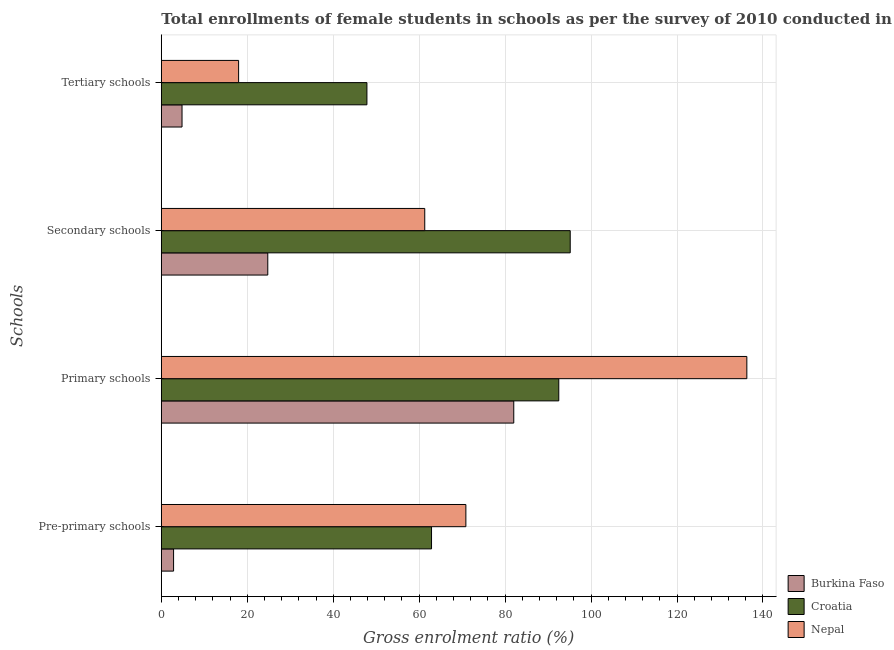How many different coloured bars are there?
Offer a very short reply. 3. How many groups of bars are there?
Offer a very short reply. 4. Are the number of bars per tick equal to the number of legend labels?
Ensure brevity in your answer.  Yes. Are the number of bars on each tick of the Y-axis equal?
Make the answer very short. Yes. What is the label of the 2nd group of bars from the top?
Provide a succinct answer. Secondary schools. What is the gross enrolment ratio(female) in primary schools in Croatia?
Provide a succinct answer. 92.49. Across all countries, what is the maximum gross enrolment ratio(female) in tertiary schools?
Make the answer very short. 47.84. Across all countries, what is the minimum gross enrolment ratio(female) in secondary schools?
Offer a very short reply. 24.77. In which country was the gross enrolment ratio(female) in primary schools maximum?
Offer a terse response. Nepal. In which country was the gross enrolment ratio(female) in primary schools minimum?
Your answer should be compact. Burkina Faso. What is the total gross enrolment ratio(female) in secondary schools in the graph?
Provide a short and direct response. 181.22. What is the difference between the gross enrolment ratio(female) in primary schools in Croatia and that in Nepal?
Provide a succinct answer. -43.76. What is the difference between the gross enrolment ratio(female) in secondary schools in Burkina Faso and the gross enrolment ratio(female) in pre-primary schools in Croatia?
Keep it short and to the point. -38.1. What is the average gross enrolment ratio(female) in primary schools per country?
Your answer should be very brief. 103.58. What is the difference between the gross enrolment ratio(female) in tertiary schools and gross enrolment ratio(female) in secondary schools in Nepal?
Ensure brevity in your answer.  -43.31. What is the ratio of the gross enrolment ratio(female) in pre-primary schools in Croatia to that in Burkina Faso?
Your response must be concise. 22.03. Is the gross enrolment ratio(female) in secondary schools in Croatia less than that in Burkina Faso?
Offer a terse response. No. What is the difference between the highest and the second highest gross enrolment ratio(female) in pre-primary schools?
Your answer should be compact. 7.99. What is the difference between the highest and the lowest gross enrolment ratio(female) in tertiary schools?
Give a very brief answer. 43.02. In how many countries, is the gross enrolment ratio(female) in primary schools greater than the average gross enrolment ratio(female) in primary schools taken over all countries?
Your response must be concise. 1. Is it the case that in every country, the sum of the gross enrolment ratio(female) in secondary schools and gross enrolment ratio(female) in tertiary schools is greater than the sum of gross enrolment ratio(female) in primary schools and gross enrolment ratio(female) in pre-primary schools?
Offer a terse response. No. What does the 2nd bar from the top in Primary schools represents?
Your answer should be very brief. Croatia. What does the 1st bar from the bottom in Primary schools represents?
Keep it short and to the point. Burkina Faso. Is it the case that in every country, the sum of the gross enrolment ratio(female) in pre-primary schools and gross enrolment ratio(female) in primary schools is greater than the gross enrolment ratio(female) in secondary schools?
Offer a very short reply. Yes. Are all the bars in the graph horizontal?
Make the answer very short. Yes. How many countries are there in the graph?
Offer a terse response. 3. Are the values on the major ticks of X-axis written in scientific E-notation?
Your answer should be very brief. No. Where does the legend appear in the graph?
Give a very brief answer. Bottom right. How are the legend labels stacked?
Offer a terse response. Vertical. What is the title of the graph?
Provide a succinct answer. Total enrollments of female students in schools as per the survey of 2010 conducted in different countries. Does "Guinea" appear as one of the legend labels in the graph?
Your response must be concise. No. What is the label or title of the Y-axis?
Offer a very short reply. Schools. What is the Gross enrolment ratio (%) in Burkina Faso in Pre-primary schools?
Provide a succinct answer. 2.85. What is the Gross enrolment ratio (%) of Croatia in Pre-primary schools?
Your answer should be compact. 62.87. What is the Gross enrolment ratio (%) in Nepal in Pre-primary schools?
Offer a terse response. 70.87. What is the Gross enrolment ratio (%) of Burkina Faso in Primary schools?
Make the answer very short. 82.01. What is the Gross enrolment ratio (%) in Croatia in Primary schools?
Provide a succinct answer. 92.49. What is the Gross enrolment ratio (%) of Nepal in Primary schools?
Provide a short and direct response. 136.24. What is the Gross enrolment ratio (%) of Burkina Faso in Secondary schools?
Make the answer very short. 24.77. What is the Gross enrolment ratio (%) in Croatia in Secondary schools?
Provide a succinct answer. 95.15. What is the Gross enrolment ratio (%) of Nepal in Secondary schools?
Make the answer very short. 61.3. What is the Gross enrolment ratio (%) in Burkina Faso in Tertiary schools?
Your answer should be very brief. 4.82. What is the Gross enrolment ratio (%) in Croatia in Tertiary schools?
Provide a succinct answer. 47.84. What is the Gross enrolment ratio (%) in Nepal in Tertiary schools?
Offer a very short reply. 17.99. Across all Schools, what is the maximum Gross enrolment ratio (%) of Burkina Faso?
Offer a terse response. 82.01. Across all Schools, what is the maximum Gross enrolment ratio (%) in Croatia?
Keep it short and to the point. 95.15. Across all Schools, what is the maximum Gross enrolment ratio (%) of Nepal?
Give a very brief answer. 136.24. Across all Schools, what is the minimum Gross enrolment ratio (%) in Burkina Faso?
Your answer should be compact. 2.85. Across all Schools, what is the minimum Gross enrolment ratio (%) of Croatia?
Make the answer very short. 47.84. Across all Schools, what is the minimum Gross enrolment ratio (%) of Nepal?
Your answer should be compact. 17.99. What is the total Gross enrolment ratio (%) of Burkina Faso in the graph?
Offer a very short reply. 114.46. What is the total Gross enrolment ratio (%) in Croatia in the graph?
Offer a very short reply. 298.35. What is the total Gross enrolment ratio (%) in Nepal in the graph?
Your response must be concise. 286.4. What is the difference between the Gross enrolment ratio (%) of Burkina Faso in Pre-primary schools and that in Primary schools?
Ensure brevity in your answer.  -79.16. What is the difference between the Gross enrolment ratio (%) in Croatia in Pre-primary schools and that in Primary schools?
Offer a terse response. -29.61. What is the difference between the Gross enrolment ratio (%) of Nepal in Pre-primary schools and that in Primary schools?
Make the answer very short. -65.38. What is the difference between the Gross enrolment ratio (%) in Burkina Faso in Pre-primary schools and that in Secondary schools?
Ensure brevity in your answer.  -21.92. What is the difference between the Gross enrolment ratio (%) in Croatia in Pre-primary schools and that in Secondary schools?
Keep it short and to the point. -32.27. What is the difference between the Gross enrolment ratio (%) in Nepal in Pre-primary schools and that in Secondary schools?
Provide a short and direct response. 9.57. What is the difference between the Gross enrolment ratio (%) in Burkina Faso in Pre-primary schools and that in Tertiary schools?
Your answer should be compact. -1.97. What is the difference between the Gross enrolment ratio (%) in Croatia in Pre-primary schools and that in Tertiary schools?
Keep it short and to the point. 15.03. What is the difference between the Gross enrolment ratio (%) in Nepal in Pre-primary schools and that in Tertiary schools?
Ensure brevity in your answer.  52.88. What is the difference between the Gross enrolment ratio (%) in Burkina Faso in Primary schools and that in Secondary schools?
Your response must be concise. 57.24. What is the difference between the Gross enrolment ratio (%) of Croatia in Primary schools and that in Secondary schools?
Keep it short and to the point. -2.66. What is the difference between the Gross enrolment ratio (%) of Nepal in Primary schools and that in Secondary schools?
Keep it short and to the point. 74.94. What is the difference between the Gross enrolment ratio (%) of Burkina Faso in Primary schools and that in Tertiary schools?
Offer a very short reply. 77.19. What is the difference between the Gross enrolment ratio (%) in Croatia in Primary schools and that in Tertiary schools?
Offer a terse response. 44.64. What is the difference between the Gross enrolment ratio (%) of Nepal in Primary schools and that in Tertiary schools?
Offer a terse response. 118.26. What is the difference between the Gross enrolment ratio (%) of Burkina Faso in Secondary schools and that in Tertiary schools?
Offer a terse response. 19.95. What is the difference between the Gross enrolment ratio (%) of Croatia in Secondary schools and that in Tertiary schools?
Ensure brevity in your answer.  47.3. What is the difference between the Gross enrolment ratio (%) in Nepal in Secondary schools and that in Tertiary schools?
Provide a succinct answer. 43.31. What is the difference between the Gross enrolment ratio (%) in Burkina Faso in Pre-primary schools and the Gross enrolment ratio (%) in Croatia in Primary schools?
Your response must be concise. -89.63. What is the difference between the Gross enrolment ratio (%) in Burkina Faso in Pre-primary schools and the Gross enrolment ratio (%) in Nepal in Primary schools?
Offer a very short reply. -133.39. What is the difference between the Gross enrolment ratio (%) in Croatia in Pre-primary schools and the Gross enrolment ratio (%) in Nepal in Primary schools?
Offer a terse response. -73.37. What is the difference between the Gross enrolment ratio (%) in Burkina Faso in Pre-primary schools and the Gross enrolment ratio (%) in Croatia in Secondary schools?
Keep it short and to the point. -92.29. What is the difference between the Gross enrolment ratio (%) in Burkina Faso in Pre-primary schools and the Gross enrolment ratio (%) in Nepal in Secondary schools?
Provide a succinct answer. -58.44. What is the difference between the Gross enrolment ratio (%) of Croatia in Pre-primary schools and the Gross enrolment ratio (%) of Nepal in Secondary schools?
Ensure brevity in your answer.  1.58. What is the difference between the Gross enrolment ratio (%) of Burkina Faso in Pre-primary schools and the Gross enrolment ratio (%) of Croatia in Tertiary schools?
Make the answer very short. -44.99. What is the difference between the Gross enrolment ratio (%) in Burkina Faso in Pre-primary schools and the Gross enrolment ratio (%) in Nepal in Tertiary schools?
Keep it short and to the point. -15.13. What is the difference between the Gross enrolment ratio (%) in Croatia in Pre-primary schools and the Gross enrolment ratio (%) in Nepal in Tertiary schools?
Offer a very short reply. 44.89. What is the difference between the Gross enrolment ratio (%) in Burkina Faso in Primary schools and the Gross enrolment ratio (%) in Croatia in Secondary schools?
Make the answer very short. -13.13. What is the difference between the Gross enrolment ratio (%) of Burkina Faso in Primary schools and the Gross enrolment ratio (%) of Nepal in Secondary schools?
Offer a terse response. 20.71. What is the difference between the Gross enrolment ratio (%) in Croatia in Primary schools and the Gross enrolment ratio (%) in Nepal in Secondary schools?
Provide a short and direct response. 31.19. What is the difference between the Gross enrolment ratio (%) of Burkina Faso in Primary schools and the Gross enrolment ratio (%) of Croatia in Tertiary schools?
Provide a succinct answer. 34.17. What is the difference between the Gross enrolment ratio (%) in Burkina Faso in Primary schools and the Gross enrolment ratio (%) in Nepal in Tertiary schools?
Ensure brevity in your answer.  64.03. What is the difference between the Gross enrolment ratio (%) of Croatia in Primary schools and the Gross enrolment ratio (%) of Nepal in Tertiary schools?
Your response must be concise. 74.5. What is the difference between the Gross enrolment ratio (%) in Burkina Faso in Secondary schools and the Gross enrolment ratio (%) in Croatia in Tertiary schools?
Ensure brevity in your answer.  -23.07. What is the difference between the Gross enrolment ratio (%) of Burkina Faso in Secondary schools and the Gross enrolment ratio (%) of Nepal in Tertiary schools?
Keep it short and to the point. 6.79. What is the difference between the Gross enrolment ratio (%) in Croatia in Secondary schools and the Gross enrolment ratio (%) in Nepal in Tertiary schools?
Your answer should be compact. 77.16. What is the average Gross enrolment ratio (%) of Burkina Faso per Schools?
Offer a very short reply. 28.61. What is the average Gross enrolment ratio (%) of Croatia per Schools?
Your answer should be very brief. 74.59. What is the average Gross enrolment ratio (%) in Nepal per Schools?
Ensure brevity in your answer.  71.6. What is the difference between the Gross enrolment ratio (%) of Burkina Faso and Gross enrolment ratio (%) of Croatia in Pre-primary schools?
Offer a terse response. -60.02. What is the difference between the Gross enrolment ratio (%) in Burkina Faso and Gross enrolment ratio (%) in Nepal in Pre-primary schools?
Provide a short and direct response. -68.01. What is the difference between the Gross enrolment ratio (%) of Croatia and Gross enrolment ratio (%) of Nepal in Pre-primary schools?
Give a very brief answer. -7.99. What is the difference between the Gross enrolment ratio (%) in Burkina Faso and Gross enrolment ratio (%) in Croatia in Primary schools?
Keep it short and to the point. -10.47. What is the difference between the Gross enrolment ratio (%) in Burkina Faso and Gross enrolment ratio (%) in Nepal in Primary schools?
Ensure brevity in your answer.  -54.23. What is the difference between the Gross enrolment ratio (%) in Croatia and Gross enrolment ratio (%) in Nepal in Primary schools?
Your answer should be compact. -43.76. What is the difference between the Gross enrolment ratio (%) in Burkina Faso and Gross enrolment ratio (%) in Croatia in Secondary schools?
Offer a terse response. -70.37. What is the difference between the Gross enrolment ratio (%) in Burkina Faso and Gross enrolment ratio (%) in Nepal in Secondary schools?
Give a very brief answer. -36.52. What is the difference between the Gross enrolment ratio (%) of Croatia and Gross enrolment ratio (%) of Nepal in Secondary schools?
Keep it short and to the point. 33.85. What is the difference between the Gross enrolment ratio (%) in Burkina Faso and Gross enrolment ratio (%) in Croatia in Tertiary schools?
Keep it short and to the point. -43.02. What is the difference between the Gross enrolment ratio (%) in Burkina Faso and Gross enrolment ratio (%) in Nepal in Tertiary schools?
Provide a succinct answer. -13.17. What is the difference between the Gross enrolment ratio (%) of Croatia and Gross enrolment ratio (%) of Nepal in Tertiary schools?
Keep it short and to the point. 29.86. What is the ratio of the Gross enrolment ratio (%) of Burkina Faso in Pre-primary schools to that in Primary schools?
Provide a short and direct response. 0.03. What is the ratio of the Gross enrolment ratio (%) in Croatia in Pre-primary schools to that in Primary schools?
Keep it short and to the point. 0.68. What is the ratio of the Gross enrolment ratio (%) of Nepal in Pre-primary schools to that in Primary schools?
Your answer should be compact. 0.52. What is the ratio of the Gross enrolment ratio (%) in Burkina Faso in Pre-primary schools to that in Secondary schools?
Ensure brevity in your answer.  0.12. What is the ratio of the Gross enrolment ratio (%) of Croatia in Pre-primary schools to that in Secondary schools?
Your answer should be very brief. 0.66. What is the ratio of the Gross enrolment ratio (%) in Nepal in Pre-primary schools to that in Secondary schools?
Offer a very short reply. 1.16. What is the ratio of the Gross enrolment ratio (%) of Burkina Faso in Pre-primary schools to that in Tertiary schools?
Offer a terse response. 0.59. What is the ratio of the Gross enrolment ratio (%) in Croatia in Pre-primary schools to that in Tertiary schools?
Offer a very short reply. 1.31. What is the ratio of the Gross enrolment ratio (%) in Nepal in Pre-primary schools to that in Tertiary schools?
Your answer should be compact. 3.94. What is the ratio of the Gross enrolment ratio (%) of Burkina Faso in Primary schools to that in Secondary schools?
Make the answer very short. 3.31. What is the ratio of the Gross enrolment ratio (%) in Croatia in Primary schools to that in Secondary schools?
Give a very brief answer. 0.97. What is the ratio of the Gross enrolment ratio (%) in Nepal in Primary schools to that in Secondary schools?
Your answer should be compact. 2.22. What is the ratio of the Gross enrolment ratio (%) of Burkina Faso in Primary schools to that in Tertiary schools?
Give a very brief answer. 17.02. What is the ratio of the Gross enrolment ratio (%) of Croatia in Primary schools to that in Tertiary schools?
Keep it short and to the point. 1.93. What is the ratio of the Gross enrolment ratio (%) of Nepal in Primary schools to that in Tertiary schools?
Give a very brief answer. 7.58. What is the ratio of the Gross enrolment ratio (%) in Burkina Faso in Secondary schools to that in Tertiary schools?
Offer a very short reply. 5.14. What is the ratio of the Gross enrolment ratio (%) of Croatia in Secondary schools to that in Tertiary schools?
Your answer should be compact. 1.99. What is the ratio of the Gross enrolment ratio (%) of Nepal in Secondary schools to that in Tertiary schools?
Provide a short and direct response. 3.41. What is the difference between the highest and the second highest Gross enrolment ratio (%) of Burkina Faso?
Your answer should be very brief. 57.24. What is the difference between the highest and the second highest Gross enrolment ratio (%) in Croatia?
Make the answer very short. 2.66. What is the difference between the highest and the second highest Gross enrolment ratio (%) of Nepal?
Offer a terse response. 65.38. What is the difference between the highest and the lowest Gross enrolment ratio (%) of Burkina Faso?
Your answer should be compact. 79.16. What is the difference between the highest and the lowest Gross enrolment ratio (%) in Croatia?
Ensure brevity in your answer.  47.3. What is the difference between the highest and the lowest Gross enrolment ratio (%) in Nepal?
Your answer should be compact. 118.26. 